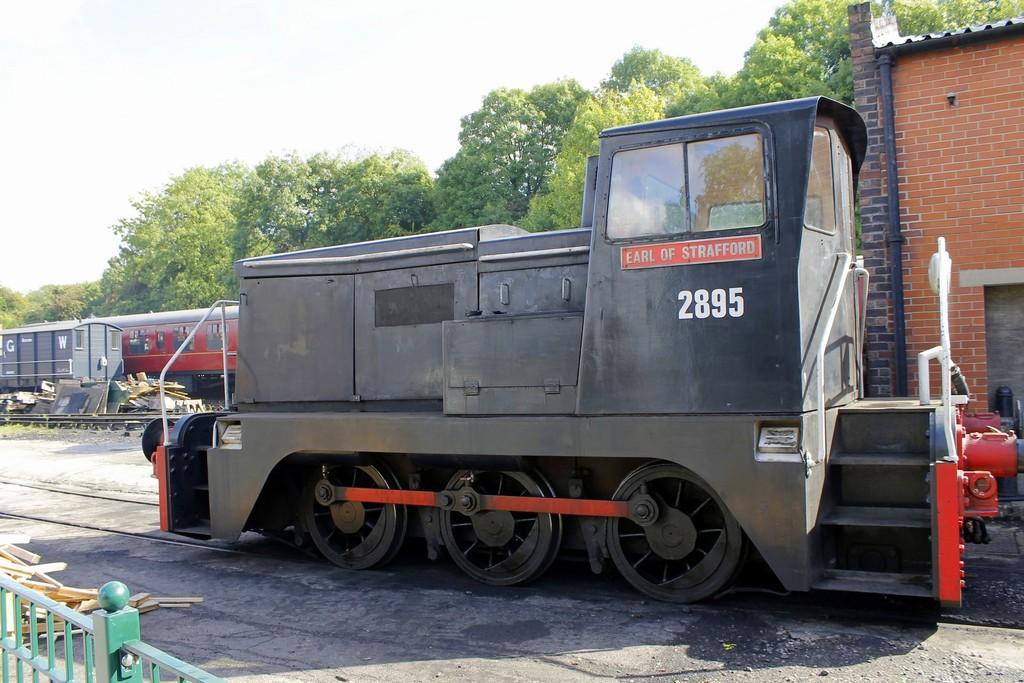Could you give a brief overview of what you see in this image? This picture might be taken from outside of the city. In this image, in the middle, we can see a train moving on the railway track. On the left corner, we can see metal grills and wood sticks. In the background, we can also see some trees, wood sticks, trees. On the top, we can see a sky, at the bottom there is a railway track and a land with some stones. 